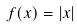Convert formula to latex. <formula><loc_0><loc_0><loc_500><loc_500>f ( x ) = | x |</formula> 